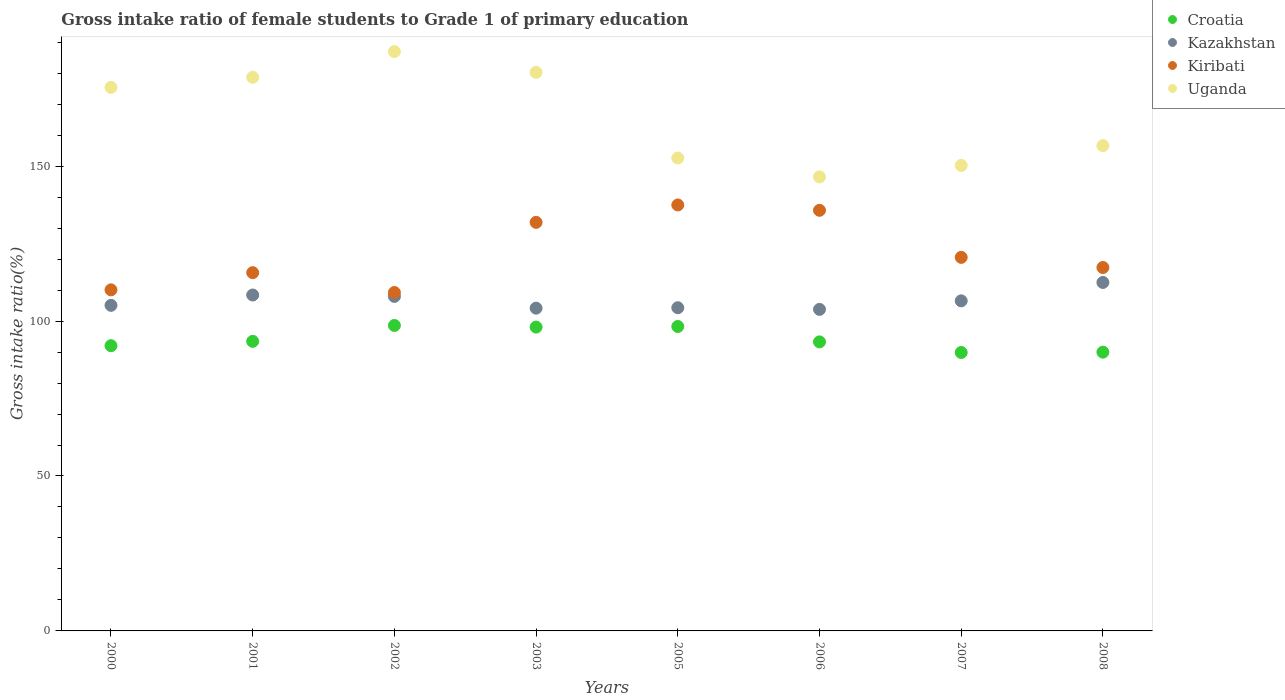Is the number of dotlines equal to the number of legend labels?
Make the answer very short. Yes. What is the gross intake ratio in Croatia in 2006?
Your answer should be compact. 93.28. Across all years, what is the maximum gross intake ratio in Croatia?
Offer a very short reply. 98.59. Across all years, what is the minimum gross intake ratio in Croatia?
Provide a succinct answer. 89.86. What is the total gross intake ratio in Kiribati in the graph?
Keep it short and to the point. 977.87. What is the difference between the gross intake ratio in Kiribati in 2001 and that in 2006?
Offer a very short reply. -20.13. What is the difference between the gross intake ratio in Croatia in 2003 and the gross intake ratio in Kazakhstan in 2007?
Give a very brief answer. -8.47. What is the average gross intake ratio in Kiribati per year?
Give a very brief answer. 122.23. In the year 2005, what is the difference between the gross intake ratio in Kiribati and gross intake ratio in Croatia?
Your answer should be very brief. 39.23. What is the ratio of the gross intake ratio in Uganda in 2002 to that in 2007?
Provide a succinct answer. 1.24. Is the gross intake ratio in Uganda in 2000 less than that in 2006?
Provide a short and direct response. No. Is the difference between the gross intake ratio in Kiribati in 2000 and 2007 greater than the difference between the gross intake ratio in Croatia in 2000 and 2007?
Provide a succinct answer. No. What is the difference between the highest and the second highest gross intake ratio in Croatia?
Provide a succinct answer. 0.33. What is the difference between the highest and the lowest gross intake ratio in Uganda?
Keep it short and to the point. 40.43. In how many years, is the gross intake ratio in Uganda greater than the average gross intake ratio in Uganda taken over all years?
Make the answer very short. 4. Does the gross intake ratio in Uganda monotonically increase over the years?
Your answer should be compact. No. Is the gross intake ratio in Kiribati strictly greater than the gross intake ratio in Uganda over the years?
Your answer should be very brief. No. How many dotlines are there?
Your answer should be very brief. 4. How many years are there in the graph?
Make the answer very short. 8. Are the values on the major ticks of Y-axis written in scientific E-notation?
Make the answer very short. No. How are the legend labels stacked?
Your response must be concise. Vertical. What is the title of the graph?
Give a very brief answer. Gross intake ratio of female students to Grade 1 of primary education. Does "Arab World" appear as one of the legend labels in the graph?
Provide a short and direct response. No. What is the label or title of the X-axis?
Keep it short and to the point. Years. What is the label or title of the Y-axis?
Ensure brevity in your answer.  Gross intake ratio(%). What is the Gross intake ratio(%) of Croatia in 2000?
Keep it short and to the point. 92.06. What is the Gross intake ratio(%) of Kazakhstan in 2000?
Offer a terse response. 105.08. What is the Gross intake ratio(%) in Kiribati in 2000?
Your answer should be compact. 110.08. What is the Gross intake ratio(%) of Uganda in 2000?
Your response must be concise. 175.42. What is the Gross intake ratio(%) in Croatia in 2001?
Keep it short and to the point. 93.46. What is the Gross intake ratio(%) in Kazakhstan in 2001?
Provide a succinct answer. 108.41. What is the Gross intake ratio(%) of Kiribati in 2001?
Give a very brief answer. 115.62. What is the Gross intake ratio(%) in Uganda in 2001?
Make the answer very short. 178.67. What is the Gross intake ratio(%) in Croatia in 2002?
Offer a terse response. 98.59. What is the Gross intake ratio(%) of Kazakhstan in 2002?
Offer a very short reply. 107.96. What is the Gross intake ratio(%) of Kiribati in 2002?
Ensure brevity in your answer.  109.23. What is the Gross intake ratio(%) in Uganda in 2002?
Your answer should be very brief. 186.96. What is the Gross intake ratio(%) of Croatia in 2003?
Offer a terse response. 98.06. What is the Gross intake ratio(%) in Kazakhstan in 2003?
Your response must be concise. 104.16. What is the Gross intake ratio(%) of Kiribati in 2003?
Make the answer very short. 131.86. What is the Gross intake ratio(%) in Uganda in 2003?
Your response must be concise. 180.28. What is the Gross intake ratio(%) of Croatia in 2005?
Your answer should be very brief. 98.25. What is the Gross intake ratio(%) of Kazakhstan in 2005?
Keep it short and to the point. 104.31. What is the Gross intake ratio(%) of Kiribati in 2005?
Offer a very short reply. 137.48. What is the Gross intake ratio(%) in Uganda in 2005?
Your answer should be very brief. 152.63. What is the Gross intake ratio(%) of Croatia in 2006?
Give a very brief answer. 93.28. What is the Gross intake ratio(%) in Kazakhstan in 2006?
Provide a succinct answer. 103.77. What is the Gross intake ratio(%) of Kiribati in 2006?
Provide a short and direct response. 135.75. What is the Gross intake ratio(%) in Uganda in 2006?
Your response must be concise. 146.53. What is the Gross intake ratio(%) of Croatia in 2007?
Make the answer very short. 89.86. What is the Gross intake ratio(%) in Kazakhstan in 2007?
Keep it short and to the point. 106.53. What is the Gross intake ratio(%) of Kiribati in 2007?
Offer a terse response. 120.56. What is the Gross intake ratio(%) of Uganda in 2007?
Ensure brevity in your answer.  150.23. What is the Gross intake ratio(%) in Croatia in 2008?
Make the answer very short. 89.97. What is the Gross intake ratio(%) of Kazakhstan in 2008?
Provide a succinct answer. 112.46. What is the Gross intake ratio(%) of Kiribati in 2008?
Make the answer very short. 117.29. What is the Gross intake ratio(%) of Uganda in 2008?
Your answer should be compact. 156.63. Across all years, what is the maximum Gross intake ratio(%) of Croatia?
Offer a very short reply. 98.59. Across all years, what is the maximum Gross intake ratio(%) in Kazakhstan?
Make the answer very short. 112.46. Across all years, what is the maximum Gross intake ratio(%) of Kiribati?
Your answer should be very brief. 137.48. Across all years, what is the maximum Gross intake ratio(%) of Uganda?
Your response must be concise. 186.96. Across all years, what is the minimum Gross intake ratio(%) of Croatia?
Provide a short and direct response. 89.86. Across all years, what is the minimum Gross intake ratio(%) of Kazakhstan?
Provide a short and direct response. 103.77. Across all years, what is the minimum Gross intake ratio(%) in Kiribati?
Your answer should be very brief. 109.23. Across all years, what is the minimum Gross intake ratio(%) of Uganda?
Your response must be concise. 146.53. What is the total Gross intake ratio(%) of Croatia in the graph?
Provide a short and direct response. 753.53. What is the total Gross intake ratio(%) in Kazakhstan in the graph?
Keep it short and to the point. 852.69. What is the total Gross intake ratio(%) of Kiribati in the graph?
Keep it short and to the point. 977.87. What is the total Gross intake ratio(%) of Uganda in the graph?
Offer a terse response. 1327.37. What is the difference between the Gross intake ratio(%) of Croatia in 2000 and that in 2001?
Keep it short and to the point. -1.4. What is the difference between the Gross intake ratio(%) in Kazakhstan in 2000 and that in 2001?
Make the answer very short. -3.33. What is the difference between the Gross intake ratio(%) in Kiribati in 2000 and that in 2001?
Provide a short and direct response. -5.54. What is the difference between the Gross intake ratio(%) of Uganda in 2000 and that in 2001?
Give a very brief answer. -3.25. What is the difference between the Gross intake ratio(%) of Croatia in 2000 and that in 2002?
Ensure brevity in your answer.  -6.53. What is the difference between the Gross intake ratio(%) in Kazakhstan in 2000 and that in 2002?
Your answer should be very brief. -2.88. What is the difference between the Gross intake ratio(%) in Kiribati in 2000 and that in 2002?
Keep it short and to the point. 0.85. What is the difference between the Gross intake ratio(%) in Uganda in 2000 and that in 2002?
Your answer should be very brief. -11.54. What is the difference between the Gross intake ratio(%) of Croatia in 2000 and that in 2003?
Offer a very short reply. -6. What is the difference between the Gross intake ratio(%) of Kazakhstan in 2000 and that in 2003?
Your answer should be very brief. 0.92. What is the difference between the Gross intake ratio(%) in Kiribati in 2000 and that in 2003?
Make the answer very short. -21.78. What is the difference between the Gross intake ratio(%) in Uganda in 2000 and that in 2003?
Ensure brevity in your answer.  -4.86. What is the difference between the Gross intake ratio(%) in Croatia in 2000 and that in 2005?
Your response must be concise. -6.2. What is the difference between the Gross intake ratio(%) in Kazakhstan in 2000 and that in 2005?
Make the answer very short. 0.77. What is the difference between the Gross intake ratio(%) in Kiribati in 2000 and that in 2005?
Keep it short and to the point. -27.4. What is the difference between the Gross intake ratio(%) of Uganda in 2000 and that in 2005?
Offer a terse response. 22.8. What is the difference between the Gross intake ratio(%) of Croatia in 2000 and that in 2006?
Provide a short and direct response. -1.23. What is the difference between the Gross intake ratio(%) of Kazakhstan in 2000 and that in 2006?
Your response must be concise. 1.31. What is the difference between the Gross intake ratio(%) in Kiribati in 2000 and that in 2006?
Offer a terse response. -25.67. What is the difference between the Gross intake ratio(%) in Uganda in 2000 and that in 2006?
Give a very brief answer. 28.89. What is the difference between the Gross intake ratio(%) in Croatia in 2000 and that in 2007?
Offer a very short reply. 2.2. What is the difference between the Gross intake ratio(%) of Kazakhstan in 2000 and that in 2007?
Your response must be concise. -1.45. What is the difference between the Gross intake ratio(%) of Kiribati in 2000 and that in 2007?
Your answer should be very brief. -10.48. What is the difference between the Gross intake ratio(%) of Uganda in 2000 and that in 2007?
Make the answer very short. 25.2. What is the difference between the Gross intake ratio(%) of Croatia in 2000 and that in 2008?
Your response must be concise. 2.09. What is the difference between the Gross intake ratio(%) of Kazakhstan in 2000 and that in 2008?
Your answer should be compact. -7.38. What is the difference between the Gross intake ratio(%) in Kiribati in 2000 and that in 2008?
Keep it short and to the point. -7.21. What is the difference between the Gross intake ratio(%) of Uganda in 2000 and that in 2008?
Your response must be concise. 18.79. What is the difference between the Gross intake ratio(%) of Croatia in 2001 and that in 2002?
Ensure brevity in your answer.  -5.13. What is the difference between the Gross intake ratio(%) of Kazakhstan in 2001 and that in 2002?
Provide a succinct answer. 0.45. What is the difference between the Gross intake ratio(%) of Kiribati in 2001 and that in 2002?
Your answer should be very brief. 6.4. What is the difference between the Gross intake ratio(%) in Uganda in 2001 and that in 2002?
Keep it short and to the point. -8.29. What is the difference between the Gross intake ratio(%) in Croatia in 2001 and that in 2003?
Your response must be concise. -4.6. What is the difference between the Gross intake ratio(%) of Kazakhstan in 2001 and that in 2003?
Keep it short and to the point. 4.25. What is the difference between the Gross intake ratio(%) in Kiribati in 2001 and that in 2003?
Offer a very short reply. -16.23. What is the difference between the Gross intake ratio(%) in Uganda in 2001 and that in 2003?
Provide a short and direct response. -1.61. What is the difference between the Gross intake ratio(%) in Croatia in 2001 and that in 2005?
Your response must be concise. -4.79. What is the difference between the Gross intake ratio(%) of Kazakhstan in 2001 and that in 2005?
Offer a very short reply. 4.1. What is the difference between the Gross intake ratio(%) of Kiribati in 2001 and that in 2005?
Give a very brief answer. -21.85. What is the difference between the Gross intake ratio(%) of Uganda in 2001 and that in 2005?
Ensure brevity in your answer.  26.05. What is the difference between the Gross intake ratio(%) of Croatia in 2001 and that in 2006?
Give a very brief answer. 0.18. What is the difference between the Gross intake ratio(%) of Kazakhstan in 2001 and that in 2006?
Give a very brief answer. 4.64. What is the difference between the Gross intake ratio(%) of Kiribati in 2001 and that in 2006?
Give a very brief answer. -20.13. What is the difference between the Gross intake ratio(%) of Uganda in 2001 and that in 2006?
Provide a succinct answer. 32.14. What is the difference between the Gross intake ratio(%) of Croatia in 2001 and that in 2007?
Your response must be concise. 3.6. What is the difference between the Gross intake ratio(%) of Kazakhstan in 2001 and that in 2007?
Your answer should be very brief. 1.88. What is the difference between the Gross intake ratio(%) in Kiribati in 2001 and that in 2007?
Give a very brief answer. -4.94. What is the difference between the Gross intake ratio(%) of Uganda in 2001 and that in 2007?
Your answer should be compact. 28.45. What is the difference between the Gross intake ratio(%) of Croatia in 2001 and that in 2008?
Provide a short and direct response. 3.49. What is the difference between the Gross intake ratio(%) in Kazakhstan in 2001 and that in 2008?
Ensure brevity in your answer.  -4.05. What is the difference between the Gross intake ratio(%) in Kiribati in 2001 and that in 2008?
Provide a short and direct response. -1.66. What is the difference between the Gross intake ratio(%) of Uganda in 2001 and that in 2008?
Make the answer very short. 22.04. What is the difference between the Gross intake ratio(%) of Croatia in 2002 and that in 2003?
Ensure brevity in your answer.  0.53. What is the difference between the Gross intake ratio(%) of Kazakhstan in 2002 and that in 2003?
Offer a very short reply. 3.8. What is the difference between the Gross intake ratio(%) of Kiribati in 2002 and that in 2003?
Ensure brevity in your answer.  -22.63. What is the difference between the Gross intake ratio(%) in Uganda in 2002 and that in 2003?
Keep it short and to the point. 6.68. What is the difference between the Gross intake ratio(%) of Croatia in 2002 and that in 2005?
Provide a short and direct response. 0.33. What is the difference between the Gross intake ratio(%) of Kazakhstan in 2002 and that in 2005?
Offer a very short reply. 3.65. What is the difference between the Gross intake ratio(%) of Kiribati in 2002 and that in 2005?
Provide a succinct answer. -28.25. What is the difference between the Gross intake ratio(%) of Uganda in 2002 and that in 2005?
Your answer should be very brief. 34.33. What is the difference between the Gross intake ratio(%) in Croatia in 2002 and that in 2006?
Keep it short and to the point. 5.3. What is the difference between the Gross intake ratio(%) in Kazakhstan in 2002 and that in 2006?
Your answer should be compact. 4.19. What is the difference between the Gross intake ratio(%) in Kiribati in 2002 and that in 2006?
Ensure brevity in your answer.  -26.52. What is the difference between the Gross intake ratio(%) of Uganda in 2002 and that in 2006?
Offer a very short reply. 40.43. What is the difference between the Gross intake ratio(%) of Croatia in 2002 and that in 2007?
Keep it short and to the point. 8.73. What is the difference between the Gross intake ratio(%) of Kazakhstan in 2002 and that in 2007?
Keep it short and to the point. 1.43. What is the difference between the Gross intake ratio(%) in Kiribati in 2002 and that in 2007?
Keep it short and to the point. -11.34. What is the difference between the Gross intake ratio(%) of Uganda in 2002 and that in 2007?
Provide a short and direct response. 36.73. What is the difference between the Gross intake ratio(%) of Croatia in 2002 and that in 2008?
Provide a succinct answer. 8.62. What is the difference between the Gross intake ratio(%) in Kazakhstan in 2002 and that in 2008?
Provide a succinct answer. -4.5. What is the difference between the Gross intake ratio(%) of Kiribati in 2002 and that in 2008?
Offer a very short reply. -8.06. What is the difference between the Gross intake ratio(%) in Uganda in 2002 and that in 2008?
Your answer should be very brief. 30.33. What is the difference between the Gross intake ratio(%) in Croatia in 2003 and that in 2005?
Keep it short and to the point. -0.19. What is the difference between the Gross intake ratio(%) in Kazakhstan in 2003 and that in 2005?
Keep it short and to the point. -0.14. What is the difference between the Gross intake ratio(%) in Kiribati in 2003 and that in 2005?
Offer a terse response. -5.62. What is the difference between the Gross intake ratio(%) of Uganda in 2003 and that in 2005?
Offer a very short reply. 27.65. What is the difference between the Gross intake ratio(%) in Croatia in 2003 and that in 2006?
Keep it short and to the point. 4.78. What is the difference between the Gross intake ratio(%) of Kazakhstan in 2003 and that in 2006?
Keep it short and to the point. 0.39. What is the difference between the Gross intake ratio(%) of Kiribati in 2003 and that in 2006?
Offer a terse response. -3.89. What is the difference between the Gross intake ratio(%) of Uganda in 2003 and that in 2006?
Make the answer very short. 33.75. What is the difference between the Gross intake ratio(%) of Croatia in 2003 and that in 2007?
Give a very brief answer. 8.2. What is the difference between the Gross intake ratio(%) of Kazakhstan in 2003 and that in 2007?
Provide a short and direct response. -2.36. What is the difference between the Gross intake ratio(%) in Kiribati in 2003 and that in 2007?
Offer a very short reply. 11.29. What is the difference between the Gross intake ratio(%) of Uganda in 2003 and that in 2007?
Ensure brevity in your answer.  30.05. What is the difference between the Gross intake ratio(%) of Croatia in 2003 and that in 2008?
Ensure brevity in your answer.  8.09. What is the difference between the Gross intake ratio(%) in Kazakhstan in 2003 and that in 2008?
Keep it short and to the point. -8.3. What is the difference between the Gross intake ratio(%) of Kiribati in 2003 and that in 2008?
Keep it short and to the point. 14.57. What is the difference between the Gross intake ratio(%) in Uganda in 2003 and that in 2008?
Your response must be concise. 23.65. What is the difference between the Gross intake ratio(%) of Croatia in 2005 and that in 2006?
Make the answer very short. 4.97. What is the difference between the Gross intake ratio(%) in Kazakhstan in 2005 and that in 2006?
Offer a terse response. 0.53. What is the difference between the Gross intake ratio(%) in Kiribati in 2005 and that in 2006?
Provide a succinct answer. 1.73. What is the difference between the Gross intake ratio(%) in Uganda in 2005 and that in 2006?
Provide a short and direct response. 6.09. What is the difference between the Gross intake ratio(%) in Croatia in 2005 and that in 2007?
Keep it short and to the point. 8.39. What is the difference between the Gross intake ratio(%) of Kazakhstan in 2005 and that in 2007?
Ensure brevity in your answer.  -2.22. What is the difference between the Gross intake ratio(%) of Kiribati in 2005 and that in 2007?
Keep it short and to the point. 16.91. What is the difference between the Gross intake ratio(%) in Uganda in 2005 and that in 2007?
Ensure brevity in your answer.  2.4. What is the difference between the Gross intake ratio(%) of Croatia in 2005 and that in 2008?
Give a very brief answer. 8.29. What is the difference between the Gross intake ratio(%) in Kazakhstan in 2005 and that in 2008?
Your answer should be very brief. -8.16. What is the difference between the Gross intake ratio(%) of Kiribati in 2005 and that in 2008?
Provide a succinct answer. 20.19. What is the difference between the Gross intake ratio(%) in Uganda in 2005 and that in 2008?
Provide a short and direct response. -4. What is the difference between the Gross intake ratio(%) in Croatia in 2006 and that in 2007?
Your response must be concise. 3.43. What is the difference between the Gross intake ratio(%) in Kazakhstan in 2006 and that in 2007?
Offer a terse response. -2.76. What is the difference between the Gross intake ratio(%) in Kiribati in 2006 and that in 2007?
Your answer should be very brief. 15.19. What is the difference between the Gross intake ratio(%) of Uganda in 2006 and that in 2007?
Your response must be concise. -3.69. What is the difference between the Gross intake ratio(%) in Croatia in 2006 and that in 2008?
Keep it short and to the point. 3.32. What is the difference between the Gross intake ratio(%) in Kazakhstan in 2006 and that in 2008?
Keep it short and to the point. -8.69. What is the difference between the Gross intake ratio(%) of Kiribati in 2006 and that in 2008?
Your response must be concise. 18.47. What is the difference between the Gross intake ratio(%) in Uganda in 2006 and that in 2008?
Your answer should be very brief. -10.1. What is the difference between the Gross intake ratio(%) of Croatia in 2007 and that in 2008?
Ensure brevity in your answer.  -0.11. What is the difference between the Gross intake ratio(%) in Kazakhstan in 2007 and that in 2008?
Keep it short and to the point. -5.93. What is the difference between the Gross intake ratio(%) in Kiribati in 2007 and that in 2008?
Offer a very short reply. 3.28. What is the difference between the Gross intake ratio(%) in Uganda in 2007 and that in 2008?
Your answer should be very brief. -6.4. What is the difference between the Gross intake ratio(%) of Croatia in 2000 and the Gross intake ratio(%) of Kazakhstan in 2001?
Make the answer very short. -16.35. What is the difference between the Gross intake ratio(%) of Croatia in 2000 and the Gross intake ratio(%) of Kiribati in 2001?
Give a very brief answer. -23.57. What is the difference between the Gross intake ratio(%) in Croatia in 2000 and the Gross intake ratio(%) in Uganda in 2001?
Offer a terse response. -86.62. What is the difference between the Gross intake ratio(%) in Kazakhstan in 2000 and the Gross intake ratio(%) in Kiribati in 2001?
Your answer should be very brief. -10.54. What is the difference between the Gross intake ratio(%) of Kazakhstan in 2000 and the Gross intake ratio(%) of Uganda in 2001?
Offer a very short reply. -73.59. What is the difference between the Gross intake ratio(%) of Kiribati in 2000 and the Gross intake ratio(%) of Uganda in 2001?
Provide a short and direct response. -68.59. What is the difference between the Gross intake ratio(%) of Croatia in 2000 and the Gross intake ratio(%) of Kazakhstan in 2002?
Provide a succinct answer. -15.9. What is the difference between the Gross intake ratio(%) of Croatia in 2000 and the Gross intake ratio(%) of Kiribati in 2002?
Offer a terse response. -17.17. What is the difference between the Gross intake ratio(%) in Croatia in 2000 and the Gross intake ratio(%) in Uganda in 2002?
Your answer should be very brief. -94.91. What is the difference between the Gross intake ratio(%) of Kazakhstan in 2000 and the Gross intake ratio(%) of Kiribati in 2002?
Ensure brevity in your answer.  -4.15. What is the difference between the Gross intake ratio(%) in Kazakhstan in 2000 and the Gross intake ratio(%) in Uganda in 2002?
Give a very brief answer. -81.88. What is the difference between the Gross intake ratio(%) in Kiribati in 2000 and the Gross intake ratio(%) in Uganda in 2002?
Give a very brief answer. -76.88. What is the difference between the Gross intake ratio(%) of Croatia in 2000 and the Gross intake ratio(%) of Kazakhstan in 2003?
Ensure brevity in your answer.  -12.11. What is the difference between the Gross intake ratio(%) in Croatia in 2000 and the Gross intake ratio(%) in Kiribati in 2003?
Give a very brief answer. -39.8. What is the difference between the Gross intake ratio(%) of Croatia in 2000 and the Gross intake ratio(%) of Uganda in 2003?
Give a very brief answer. -88.22. What is the difference between the Gross intake ratio(%) of Kazakhstan in 2000 and the Gross intake ratio(%) of Kiribati in 2003?
Keep it short and to the point. -26.78. What is the difference between the Gross intake ratio(%) in Kazakhstan in 2000 and the Gross intake ratio(%) in Uganda in 2003?
Keep it short and to the point. -75.2. What is the difference between the Gross intake ratio(%) in Kiribati in 2000 and the Gross intake ratio(%) in Uganda in 2003?
Ensure brevity in your answer.  -70.2. What is the difference between the Gross intake ratio(%) in Croatia in 2000 and the Gross intake ratio(%) in Kazakhstan in 2005?
Make the answer very short. -12.25. What is the difference between the Gross intake ratio(%) of Croatia in 2000 and the Gross intake ratio(%) of Kiribati in 2005?
Offer a terse response. -45.42. What is the difference between the Gross intake ratio(%) of Croatia in 2000 and the Gross intake ratio(%) of Uganda in 2005?
Offer a terse response. -60.57. What is the difference between the Gross intake ratio(%) in Kazakhstan in 2000 and the Gross intake ratio(%) in Kiribati in 2005?
Give a very brief answer. -32.4. What is the difference between the Gross intake ratio(%) in Kazakhstan in 2000 and the Gross intake ratio(%) in Uganda in 2005?
Keep it short and to the point. -47.55. What is the difference between the Gross intake ratio(%) in Kiribati in 2000 and the Gross intake ratio(%) in Uganda in 2005?
Provide a succinct answer. -42.55. What is the difference between the Gross intake ratio(%) of Croatia in 2000 and the Gross intake ratio(%) of Kazakhstan in 2006?
Ensure brevity in your answer.  -11.72. What is the difference between the Gross intake ratio(%) in Croatia in 2000 and the Gross intake ratio(%) in Kiribati in 2006?
Give a very brief answer. -43.7. What is the difference between the Gross intake ratio(%) of Croatia in 2000 and the Gross intake ratio(%) of Uganda in 2006?
Give a very brief answer. -54.48. What is the difference between the Gross intake ratio(%) in Kazakhstan in 2000 and the Gross intake ratio(%) in Kiribati in 2006?
Your answer should be very brief. -30.67. What is the difference between the Gross intake ratio(%) of Kazakhstan in 2000 and the Gross intake ratio(%) of Uganda in 2006?
Offer a terse response. -41.45. What is the difference between the Gross intake ratio(%) in Kiribati in 2000 and the Gross intake ratio(%) in Uganda in 2006?
Provide a succinct answer. -36.45. What is the difference between the Gross intake ratio(%) in Croatia in 2000 and the Gross intake ratio(%) in Kazakhstan in 2007?
Your answer should be compact. -14.47. What is the difference between the Gross intake ratio(%) in Croatia in 2000 and the Gross intake ratio(%) in Kiribati in 2007?
Your answer should be compact. -28.51. What is the difference between the Gross intake ratio(%) in Croatia in 2000 and the Gross intake ratio(%) in Uganda in 2007?
Make the answer very short. -58.17. What is the difference between the Gross intake ratio(%) in Kazakhstan in 2000 and the Gross intake ratio(%) in Kiribati in 2007?
Offer a terse response. -15.48. What is the difference between the Gross intake ratio(%) of Kazakhstan in 2000 and the Gross intake ratio(%) of Uganda in 2007?
Your answer should be compact. -45.15. What is the difference between the Gross intake ratio(%) in Kiribati in 2000 and the Gross intake ratio(%) in Uganda in 2007?
Your answer should be compact. -40.15. What is the difference between the Gross intake ratio(%) in Croatia in 2000 and the Gross intake ratio(%) in Kazakhstan in 2008?
Offer a terse response. -20.41. What is the difference between the Gross intake ratio(%) in Croatia in 2000 and the Gross intake ratio(%) in Kiribati in 2008?
Provide a succinct answer. -25.23. What is the difference between the Gross intake ratio(%) of Croatia in 2000 and the Gross intake ratio(%) of Uganda in 2008?
Make the answer very short. -64.58. What is the difference between the Gross intake ratio(%) of Kazakhstan in 2000 and the Gross intake ratio(%) of Kiribati in 2008?
Provide a succinct answer. -12.21. What is the difference between the Gross intake ratio(%) in Kazakhstan in 2000 and the Gross intake ratio(%) in Uganda in 2008?
Offer a very short reply. -51.55. What is the difference between the Gross intake ratio(%) in Kiribati in 2000 and the Gross intake ratio(%) in Uganda in 2008?
Your answer should be compact. -46.55. What is the difference between the Gross intake ratio(%) in Croatia in 2001 and the Gross intake ratio(%) in Kazakhstan in 2002?
Ensure brevity in your answer.  -14.5. What is the difference between the Gross intake ratio(%) of Croatia in 2001 and the Gross intake ratio(%) of Kiribati in 2002?
Your answer should be very brief. -15.77. What is the difference between the Gross intake ratio(%) of Croatia in 2001 and the Gross intake ratio(%) of Uganda in 2002?
Your response must be concise. -93.5. What is the difference between the Gross intake ratio(%) in Kazakhstan in 2001 and the Gross intake ratio(%) in Kiribati in 2002?
Your answer should be very brief. -0.82. What is the difference between the Gross intake ratio(%) in Kazakhstan in 2001 and the Gross intake ratio(%) in Uganda in 2002?
Provide a short and direct response. -78.55. What is the difference between the Gross intake ratio(%) in Kiribati in 2001 and the Gross intake ratio(%) in Uganda in 2002?
Make the answer very short. -71.34. What is the difference between the Gross intake ratio(%) in Croatia in 2001 and the Gross intake ratio(%) in Kazakhstan in 2003?
Your answer should be very brief. -10.7. What is the difference between the Gross intake ratio(%) of Croatia in 2001 and the Gross intake ratio(%) of Kiribati in 2003?
Ensure brevity in your answer.  -38.4. What is the difference between the Gross intake ratio(%) in Croatia in 2001 and the Gross intake ratio(%) in Uganda in 2003?
Offer a terse response. -86.82. What is the difference between the Gross intake ratio(%) of Kazakhstan in 2001 and the Gross intake ratio(%) of Kiribati in 2003?
Your answer should be very brief. -23.45. What is the difference between the Gross intake ratio(%) of Kazakhstan in 2001 and the Gross intake ratio(%) of Uganda in 2003?
Your answer should be very brief. -71.87. What is the difference between the Gross intake ratio(%) in Kiribati in 2001 and the Gross intake ratio(%) in Uganda in 2003?
Your answer should be very brief. -64.66. What is the difference between the Gross intake ratio(%) in Croatia in 2001 and the Gross intake ratio(%) in Kazakhstan in 2005?
Your answer should be compact. -10.85. What is the difference between the Gross intake ratio(%) in Croatia in 2001 and the Gross intake ratio(%) in Kiribati in 2005?
Give a very brief answer. -44.02. What is the difference between the Gross intake ratio(%) in Croatia in 2001 and the Gross intake ratio(%) in Uganda in 2005?
Make the answer very short. -59.17. What is the difference between the Gross intake ratio(%) in Kazakhstan in 2001 and the Gross intake ratio(%) in Kiribati in 2005?
Your answer should be compact. -29.07. What is the difference between the Gross intake ratio(%) of Kazakhstan in 2001 and the Gross intake ratio(%) of Uganda in 2005?
Give a very brief answer. -44.22. What is the difference between the Gross intake ratio(%) in Kiribati in 2001 and the Gross intake ratio(%) in Uganda in 2005?
Your response must be concise. -37. What is the difference between the Gross intake ratio(%) of Croatia in 2001 and the Gross intake ratio(%) of Kazakhstan in 2006?
Offer a terse response. -10.31. What is the difference between the Gross intake ratio(%) of Croatia in 2001 and the Gross intake ratio(%) of Kiribati in 2006?
Keep it short and to the point. -42.29. What is the difference between the Gross intake ratio(%) of Croatia in 2001 and the Gross intake ratio(%) of Uganda in 2006?
Provide a succinct answer. -53.07. What is the difference between the Gross intake ratio(%) in Kazakhstan in 2001 and the Gross intake ratio(%) in Kiribati in 2006?
Provide a succinct answer. -27.34. What is the difference between the Gross intake ratio(%) of Kazakhstan in 2001 and the Gross intake ratio(%) of Uganda in 2006?
Your answer should be very brief. -38.12. What is the difference between the Gross intake ratio(%) of Kiribati in 2001 and the Gross intake ratio(%) of Uganda in 2006?
Make the answer very short. -30.91. What is the difference between the Gross intake ratio(%) of Croatia in 2001 and the Gross intake ratio(%) of Kazakhstan in 2007?
Provide a short and direct response. -13.07. What is the difference between the Gross intake ratio(%) in Croatia in 2001 and the Gross intake ratio(%) in Kiribati in 2007?
Give a very brief answer. -27.1. What is the difference between the Gross intake ratio(%) of Croatia in 2001 and the Gross intake ratio(%) of Uganda in 2007?
Offer a terse response. -56.77. What is the difference between the Gross intake ratio(%) of Kazakhstan in 2001 and the Gross intake ratio(%) of Kiribati in 2007?
Offer a terse response. -12.15. What is the difference between the Gross intake ratio(%) of Kazakhstan in 2001 and the Gross intake ratio(%) of Uganda in 2007?
Your answer should be compact. -41.82. What is the difference between the Gross intake ratio(%) of Kiribati in 2001 and the Gross intake ratio(%) of Uganda in 2007?
Offer a terse response. -34.6. What is the difference between the Gross intake ratio(%) of Croatia in 2001 and the Gross intake ratio(%) of Kazakhstan in 2008?
Ensure brevity in your answer.  -19. What is the difference between the Gross intake ratio(%) in Croatia in 2001 and the Gross intake ratio(%) in Kiribati in 2008?
Your response must be concise. -23.83. What is the difference between the Gross intake ratio(%) in Croatia in 2001 and the Gross intake ratio(%) in Uganda in 2008?
Give a very brief answer. -63.17. What is the difference between the Gross intake ratio(%) in Kazakhstan in 2001 and the Gross intake ratio(%) in Kiribati in 2008?
Your response must be concise. -8.88. What is the difference between the Gross intake ratio(%) of Kazakhstan in 2001 and the Gross intake ratio(%) of Uganda in 2008?
Your answer should be compact. -48.22. What is the difference between the Gross intake ratio(%) of Kiribati in 2001 and the Gross intake ratio(%) of Uganda in 2008?
Provide a succinct answer. -41.01. What is the difference between the Gross intake ratio(%) in Croatia in 2002 and the Gross intake ratio(%) in Kazakhstan in 2003?
Offer a very short reply. -5.58. What is the difference between the Gross intake ratio(%) of Croatia in 2002 and the Gross intake ratio(%) of Kiribati in 2003?
Your response must be concise. -33.27. What is the difference between the Gross intake ratio(%) of Croatia in 2002 and the Gross intake ratio(%) of Uganda in 2003?
Your answer should be compact. -81.69. What is the difference between the Gross intake ratio(%) in Kazakhstan in 2002 and the Gross intake ratio(%) in Kiribati in 2003?
Offer a terse response. -23.9. What is the difference between the Gross intake ratio(%) in Kazakhstan in 2002 and the Gross intake ratio(%) in Uganda in 2003?
Provide a short and direct response. -72.32. What is the difference between the Gross intake ratio(%) of Kiribati in 2002 and the Gross intake ratio(%) of Uganda in 2003?
Give a very brief answer. -71.05. What is the difference between the Gross intake ratio(%) of Croatia in 2002 and the Gross intake ratio(%) of Kazakhstan in 2005?
Provide a succinct answer. -5.72. What is the difference between the Gross intake ratio(%) in Croatia in 2002 and the Gross intake ratio(%) in Kiribati in 2005?
Provide a short and direct response. -38.89. What is the difference between the Gross intake ratio(%) in Croatia in 2002 and the Gross intake ratio(%) in Uganda in 2005?
Keep it short and to the point. -54.04. What is the difference between the Gross intake ratio(%) in Kazakhstan in 2002 and the Gross intake ratio(%) in Kiribati in 2005?
Give a very brief answer. -29.52. What is the difference between the Gross intake ratio(%) in Kazakhstan in 2002 and the Gross intake ratio(%) in Uganda in 2005?
Offer a very short reply. -44.67. What is the difference between the Gross intake ratio(%) in Kiribati in 2002 and the Gross intake ratio(%) in Uganda in 2005?
Provide a succinct answer. -43.4. What is the difference between the Gross intake ratio(%) of Croatia in 2002 and the Gross intake ratio(%) of Kazakhstan in 2006?
Your answer should be compact. -5.19. What is the difference between the Gross intake ratio(%) in Croatia in 2002 and the Gross intake ratio(%) in Kiribati in 2006?
Offer a very short reply. -37.17. What is the difference between the Gross intake ratio(%) of Croatia in 2002 and the Gross intake ratio(%) of Uganda in 2006?
Make the answer very short. -47.95. What is the difference between the Gross intake ratio(%) of Kazakhstan in 2002 and the Gross intake ratio(%) of Kiribati in 2006?
Provide a succinct answer. -27.79. What is the difference between the Gross intake ratio(%) in Kazakhstan in 2002 and the Gross intake ratio(%) in Uganda in 2006?
Offer a very short reply. -38.57. What is the difference between the Gross intake ratio(%) of Kiribati in 2002 and the Gross intake ratio(%) of Uganda in 2006?
Provide a succinct answer. -37.31. What is the difference between the Gross intake ratio(%) in Croatia in 2002 and the Gross intake ratio(%) in Kazakhstan in 2007?
Give a very brief answer. -7.94. What is the difference between the Gross intake ratio(%) of Croatia in 2002 and the Gross intake ratio(%) of Kiribati in 2007?
Provide a short and direct response. -21.98. What is the difference between the Gross intake ratio(%) in Croatia in 2002 and the Gross intake ratio(%) in Uganda in 2007?
Your answer should be compact. -51.64. What is the difference between the Gross intake ratio(%) in Kazakhstan in 2002 and the Gross intake ratio(%) in Kiribati in 2007?
Keep it short and to the point. -12.6. What is the difference between the Gross intake ratio(%) in Kazakhstan in 2002 and the Gross intake ratio(%) in Uganda in 2007?
Your response must be concise. -42.27. What is the difference between the Gross intake ratio(%) of Kiribati in 2002 and the Gross intake ratio(%) of Uganda in 2007?
Make the answer very short. -41. What is the difference between the Gross intake ratio(%) in Croatia in 2002 and the Gross intake ratio(%) in Kazakhstan in 2008?
Offer a very short reply. -13.88. What is the difference between the Gross intake ratio(%) in Croatia in 2002 and the Gross intake ratio(%) in Kiribati in 2008?
Give a very brief answer. -18.7. What is the difference between the Gross intake ratio(%) of Croatia in 2002 and the Gross intake ratio(%) of Uganda in 2008?
Your answer should be very brief. -58.05. What is the difference between the Gross intake ratio(%) in Kazakhstan in 2002 and the Gross intake ratio(%) in Kiribati in 2008?
Provide a short and direct response. -9.33. What is the difference between the Gross intake ratio(%) of Kazakhstan in 2002 and the Gross intake ratio(%) of Uganda in 2008?
Offer a terse response. -48.67. What is the difference between the Gross intake ratio(%) in Kiribati in 2002 and the Gross intake ratio(%) in Uganda in 2008?
Your answer should be very brief. -47.41. What is the difference between the Gross intake ratio(%) of Croatia in 2003 and the Gross intake ratio(%) of Kazakhstan in 2005?
Ensure brevity in your answer.  -6.25. What is the difference between the Gross intake ratio(%) of Croatia in 2003 and the Gross intake ratio(%) of Kiribati in 2005?
Provide a short and direct response. -39.42. What is the difference between the Gross intake ratio(%) of Croatia in 2003 and the Gross intake ratio(%) of Uganda in 2005?
Offer a very short reply. -54.57. What is the difference between the Gross intake ratio(%) in Kazakhstan in 2003 and the Gross intake ratio(%) in Kiribati in 2005?
Keep it short and to the point. -33.31. What is the difference between the Gross intake ratio(%) in Kazakhstan in 2003 and the Gross intake ratio(%) in Uganda in 2005?
Your response must be concise. -48.46. What is the difference between the Gross intake ratio(%) in Kiribati in 2003 and the Gross intake ratio(%) in Uganda in 2005?
Your response must be concise. -20.77. What is the difference between the Gross intake ratio(%) of Croatia in 2003 and the Gross intake ratio(%) of Kazakhstan in 2006?
Keep it short and to the point. -5.71. What is the difference between the Gross intake ratio(%) of Croatia in 2003 and the Gross intake ratio(%) of Kiribati in 2006?
Your answer should be compact. -37.69. What is the difference between the Gross intake ratio(%) of Croatia in 2003 and the Gross intake ratio(%) of Uganda in 2006?
Your answer should be compact. -48.47. What is the difference between the Gross intake ratio(%) of Kazakhstan in 2003 and the Gross intake ratio(%) of Kiribati in 2006?
Your response must be concise. -31.59. What is the difference between the Gross intake ratio(%) of Kazakhstan in 2003 and the Gross intake ratio(%) of Uganda in 2006?
Keep it short and to the point. -42.37. What is the difference between the Gross intake ratio(%) of Kiribati in 2003 and the Gross intake ratio(%) of Uganda in 2006?
Your response must be concise. -14.68. What is the difference between the Gross intake ratio(%) in Croatia in 2003 and the Gross intake ratio(%) in Kazakhstan in 2007?
Offer a very short reply. -8.47. What is the difference between the Gross intake ratio(%) in Croatia in 2003 and the Gross intake ratio(%) in Kiribati in 2007?
Ensure brevity in your answer.  -22.5. What is the difference between the Gross intake ratio(%) in Croatia in 2003 and the Gross intake ratio(%) in Uganda in 2007?
Make the answer very short. -52.17. What is the difference between the Gross intake ratio(%) of Kazakhstan in 2003 and the Gross intake ratio(%) of Kiribati in 2007?
Your response must be concise. -16.4. What is the difference between the Gross intake ratio(%) in Kazakhstan in 2003 and the Gross intake ratio(%) in Uganda in 2007?
Offer a very short reply. -46.06. What is the difference between the Gross intake ratio(%) of Kiribati in 2003 and the Gross intake ratio(%) of Uganda in 2007?
Make the answer very short. -18.37. What is the difference between the Gross intake ratio(%) of Croatia in 2003 and the Gross intake ratio(%) of Kazakhstan in 2008?
Provide a short and direct response. -14.4. What is the difference between the Gross intake ratio(%) in Croatia in 2003 and the Gross intake ratio(%) in Kiribati in 2008?
Provide a short and direct response. -19.23. What is the difference between the Gross intake ratio(%) in Croatia in 2003 and the Gross intake ratio(%) in Uganda in 2008?
Offer a terse response. -58.57. What is the difference between the Gross intake ratio(%) in Kazakhstan in 2003 and the Gross intake ratio(%) in Kiribati in 2008?
Provide a succinct answer. -13.12. What is the difference between the Gross intake ratio(%) of Kazakhstan in 2003 and the Gross intake ratio(%) of Uganda in 2008?
Give a very brief answer. -52.47. What is the difference between the Gross intake ratio(%) in Kiribati in 2003 and the Gross intake ratio(%) in Uganda in 2008?
Your answer should be very brief. -24.77. What is the difference between the Gross intake ratio(%) of Croatia in 2005 and the Gross intake ratio(%) of Kazakhstan in 2006?
Keep it short and to the point. -5.52. What is the difference between the Gross intake ratio(%) of Croatia in 2005 and the Gross intake ratio(%) of Kiribati in 2006?
Make the answer very short. -37.5. What is the difference between the Gross intake ratio(%) of Croatia in 2005 and the Gross intake ratio(%) of Uganda in 2006?
Offer a terse response. -48.28. What is the difference between the Gross intake ratio(%) in Kazakhstan in 2005 and the Gross intake ratio(%) in Kiribati in 2006?
Provide a succinct answer. -31.45. What is the difference between the Gross intake ratio(%) in Kazakhstan in 2005 and the Gross intake ratio(%) in Uganda in 2006?
Give a very brief answer. -42.23. What is the difference between the Gross intake ratio(%) in Kiribati in 2005 and the Gross intake ratio(%) in Uganda in 2006?
Provide a short and direct response. -9.06. What is the difference between the Gross intake ratio(%) of Croatia in 2005 and the Gross intake ratio(%) of Kazakhstan in 2007?
Provide a short and direct response. -8.28. What is the difference between the Gross intake ratio(%) in Croatia in 2005 and the Gross intake ratio(%) in Kiribati in 2007?
Your answer should be very brief. -22.31. What is the difference between the Gross intake ratio(%) of Croatia in 2005 and the Gross intake ratio(%) of Uganda in 2007?
Provide a short and direct response. -51.98. What is the difference between the Gross intake ratio(%) in Kazakhstan in 2005 and the Gross intake ratio(%) in Kiribati in 2007?
Your answer should be compact. -16.26. What is the difference between the Gross intake ratio(%) in Kazakhstan in 2005 and the Gross intake ratio(%) in Uganda in 2007?
Offer a terse response. -45.92. What is the difference between the Gross intake ratio(%) of Kiribati in 2005 and the Gross intake ratio(%) of Uganda in 2007?
Your answer should be compact. -12.75. What is the difference between the Gross intake ratio(%) in Croatia in 2005 and the Gross intake ratio(%) in Kazakhstan in 2008?
Offer a very short reply. -14.21. What is the difference between the Gross intake ratio(%) of Croatia in 2005 and the Gross intake ratio(%) of Kiribati in 2008?
Offer a terse response. -19.03. What is the difference between the Gross intake ratio(%) in Croatia in 2005 and the Gross intake ratio(%) in Uganda in 2008?
Offer a very short reply. -58.38. What is the difference between the Gross intake ratio(%) in Kazakhstan in 2005 and the Gross intake ratio(%) in Kiribati in 2008?
Provide a succinct answer. -12.98. What is the difference between the Gross intake ratio(%) in Kazakhstan in 2005 and the Gross intake ratio(%) in Uganda in 2008?
Your answer should be compact. -52.33. What is the difference between the Gross intake ratio(%) in Kiribati in 2005 and the Gross intake ratio(%) in Uganda in 2008?
Your answer should be compact. -19.16. What is the difference between the Gross intake ratio(%) in Croatia in 2006 and the Gross intake ratio(%) in Kazakhstan in 2007?
Your response must be concise. -13.24. What is the difference between the Gross intake ratio(%) of Croatia in 2006 and the Gross intake ratio(%) of Kiribati in 2007?
Offer a very short reply. -27.28. What is the difference between the Gross intake ratio(%) in Croatia in 2006 and the Gross intake ratio(%) in Uganda in 2007?
Provide a succinct answer. -56.94. What is the difference between the Gross intake ratio(%) of Kazakhstan in 2006 and the Gross intake ratio(%) of Kiribati in 2007?
Offer a terse response. -16.79. What is the difference between the Gross intake ratio(%) in Kazakhstan in 2006 and the Gross intake ratio(%) in Uganda in 2007?
Provide a short and direct response. -46.46. What is the difference between the Gross intake ratio(%) in Kiribati in 2006 and the Gross intake ratio(%) in Uganda in 2007?
Provide a succinct answer. -14.48. What is the difference between the Gross intake ratio(%) of Croatia in 2006 and the Gross intake ratio(%) of Kazakhstan in 2008?
Provide a succinct answer. -19.18. What is the difference between the Gross intake ratio(%) of Croatia in 2006 and the Gross intake ratio(%) of Kiribati in 2008?
Keep it short and to the point. -24. What is the difference between the Gross intake ratio(%) of Croatia in 2006 and the Gross intake ratio(%) of Uganda in 2008?
Your response must be concise. -63.35. What is the difference between the Gross intake ratio(%) in Kazakhstan in 2006 and the Gross intake ratio(%) in Kiribati in 2008?
Your answer should be very brief. -13.51. What is the difference between the Gross intake ratio(%) of Kazakhstan in 2006 and the Gross intake ratio(%) of Uganda in 2008?
Your response must be concise. -52.86. What is the difference between the Gross intake ratio(%) in Kiribati in 2006 and the Gross intake ratio(%) in Uganda in 2008?
Keep it short and to the point. -20.88. What is the difference between the Gross intake ratio(%) in Croatia in 2007 and the Gross intake ratio(%) in Kazakhstan in 2008?
Offer a terse response. -22.6. What is the difference between the Gross intake ratio(%) of Croatia in 2007 and the Gross intake ratio(%) of Kiribati in 2008?
Provide a short and direct response. -27.43. What is the difference between the Gross intake ratio(%) in Croatia in 2007 and the Gross intake ratio(%) in Uganda in 2008?
Provide a short and direct response. -66.77. What is the difference between the Gross intake ratio(%) in Kazakhstan in 2007 and the Gross intake ratio(%) in Kiribati in 2008?
Your answer should be compact. -10.76. What is the difference between the Gross intake ratio(%) of Kazakhstan in 2007 and the Gross intake ratio(%) of Uganda in 2008?
Provide a short and direct response. -50.1. What is the difference between the Gross intake ratio(%) of Kiribati in 2007 and the Gross intake ratio(%) of Uganda in 2008?
Make the answer very short. -36.07. What is the average Gross intake ratio(%) in Croatia per year?
Your response must be concise. 94.19. What is the average Gross intake ratio(%) of Kazakhstan per year?
Give a very brief answer. 106.59. What is the average Gross intake ratio(%) in Kiribati per year?
Offer a terse response. 122.23. What is the average Gross intake ratio(%) of Uganda per year?
Keep it short and to the point. 165.92. In the year 2000, what is the difference between the Gross intake ratio(%) in Croatia and Gross intake ratio(%) in Kazakhstan?
Make the answer very short. -13.02. In the year 2000, what is the difference between the Gross intake ratio(%) in Croatia and Gross intake ratio(%) in Kiribati?
Make the answer very short. -18.02. In the year 2000, what is the difference between the Gross intake ratio(%) of Croatia and Gross intake ratio(%) of Uganda?
Give a very brief answer. -83.37. In the year 2000, what is the difference between the Gross intake ratio(%) of Kazakhstan and Gross intake ratio(%) of Kiribati?
Give a very brief answer. -5. In the year 2000, what is the difference between the Gross intake ratio(%) of Kazakhstan and Gross intake ratio(%) of Uganda?
Provide a succinct answer. -70.34. In the year 2000, what is the difference between the Gross intake ratio(%) in Kiribati and Gross intake ratio(%) in Uganda?
Offer a terse response. -65.34. In the year 2001, what is the difference between the Gross intake ratio(%) of Croatia and Gross intake ratio(%) of Kazakhstan?
Give a very brief answer. -14.95. In the year 2001, what is the difference between the Gross intake ratio(%) in Croatia and Gross intake ratio(%) in Kiribati?
Ensure brevity in your answer.  -22.16. In the year 2001, what is the difference between the Gross intake ratio(%) of Croatia and Gross intake ratio(%) of Uganda?
Your answer should be very brief. -85.21. In the year 2001, what is the difference between the Gross intake ratio(%) of Kazakhstan and Gross intake ratio(%) of Kiribati?
Offer a terse response. -7.22. In the year 2001, what is the difference between the Gross intake ratio(%) of Kazakhstan and Gross intake ratio(%) of Uganda?
Provide a succinct answer. -70.26. In the year 2001, what is the difference between the Gross intake ratio(%) of Kiribati and Gross intake ratio(%) of Uganda?
Your response must be concise. -63.05. In the year 2002, what is the difference between the Gross intake ratio(%) in Croatia and Gross intake ratio(%) in Kazakhstan?
Offer a terse response. -9.37. In the year 2002, what is the difference between the Gross intake ratio(%) in Croatia and Gross intake ratio(%) in Kiribati?
Give a very brief answer. -10.64. In the year 2002, what is the difference between the Gross intake ratio(%) in Croatia and Gross intake ratio(%) in Uganda?
Your answer should be very brief. -88.38. In the year 2002, what is the difference between the Gross intake ratio(%) of Kazakhstan and Gross intake ratio(%) of Kiribati?
Offer a terse response. -1.27. In the year 2002, what is the difference between the Gross intake ratio(%) in Kazakhstan and Gross intake ratio(%) in Uganda?
Ensure brevity in your answer.  -79. In the year 2002, what is the difference between the Gross intake ratio(%) in Kiribati and Gross intake ratio(%) in Uganda?
Offer a terse response. -77.74. In the year 2003, what is the difference between the Gross intake ratio(%) in Croatia and Gross intake ratio(%) in Kazakhstan?
Provide a short and direct response. -6.1. In the year 2003, what is the difference between the Gross intake ratio(%) in Croatia and Gross intake ratio(%) in Kiribati?
Provide a succinct answer. -33.8. In the year 2003, what is the difference between the Gross intake ratio(%) in Croatia and Gross intake ratio(%) in Uganda?
Give a very brief answer. -82.22. In the year 2003, what is the difference between the Gross intake ratio(%) in Kazakhstan and Gross intake ratio(%) in Kiribati?
Your answer should be very brief. -27.69. In the year 2003, what is the difference between the Gross intake ratio(%) of Kazakhstan and Gross intake ratio(%) of Uganda?
Your answer should be very brief. -76.12. In the year 2003, what is the difference between the Gross intake ratio(%) of Kiribati and Gross intake ratio(%) of Uganda?
Keep it short and to the point. -48.42. In the year 2005, what is the difference between the Gross intake ratio(%) of Croatia and Gross intake ratio(%) of Kazakhstan?
Offer a terse response. -6.06. In the year 2005, what is the difference between the Gross intake ratio(%) in Croatia and Gross intake ratio(%) in Kiribati?
Your answer should be compact. -39.23. In the year 2005, what is the difference between the Gross intake ratio(%) in Croatia and Gross intake ratio(%) in Uganda?
Offer a very short reply. -54.38. In the year 2005, what is the difference between the Gross intake ratio(%) of Kazakhstan and Gross intake ratio(%) of Kiribati?
Provide a succinct answer. -33.17. In the year 2005, what is the difference between the Gross intake ratio(%) in Kazakhstan and Gross intake ratio(%) in Uganda?
Your response must be concise. -48.32. In the year 2005, what is the difference between the Gross intake ratio(%) of Kiribati and Gross intake ratio(%) of Uganda?
Your response must be concise. -15.15. In the year 2006, what is the difference between the Gross intake ratio(%) of Croatia and Gross intake ratio(%) of Kazakhstan?
Provide a succinct answer. -10.49. In the year 2006, what is the difference between the Gross intake ratio(%) in Croatia and Gross intake ratio(%) in Kiribati?
Provide a short and direct response. -42.47. In the year 2006, what is the difference between the Gross intake ratio(%) in Croatia and Gross intake ratio(%) in Uganda?
Make the answer very short. -53.25. In the year 2006, what is the difference between the Gross intake ratio(%) in Kazakhstan and Gross intake ratio(%) in Kiribati?
Offer a very short reply. -31.98. In the year 2006, what is the difference between the Gross intake ratio(%) of Kazakhstan and Gross intake ratio(%) of Uganda?
Your answer should be compact. -42.76. In the year 2006, what is the difference between the Gross intake ratio(%) in Kiribati and Gross intake ratio(%) in Uganda?
Ensure brevity in your answer.  -10.78. In the year 2007, what is the difference between the Gross intake ratio(%) in Croatia and Gross intake ratio(%) in Kazakhstan?
Offer a very short reply. -16.67. In the year 2007, what is the difference between the Gross intake ratio(%) of Croatia and Gross intake ratio(%) of Kiribati?
Offer a very short reply. -30.71. In the year 2007, what is the difference between the Gross intake ratio(%) of Croatia and Gross intake ratio(%) of Uganda?
Offer a terse response. -60.37. In the year 2007, what is the difference between the Gross intake ratio(%) in Kazakhstan and Gross intake ratio(%) in Kiribati?
Your response must be concise. -14.04. In the year 2007, what is the difference between the Gross intake ratio(%) in Kazakhstan and Gross intake ratio(%) in Uganda?
Provide a short and direct response. -43.7. In the year 2007, what is the difference between the Gross intake ratio(%) of Kiribati and Gross intake ratio(%) of Uganda?
Give a very brief answer. -29.66. In the year 2008, what is the difference between the Gross intake ratio(%) in Croatia and Gross intake ratio(%) in Kazakhstan?
Give a very brief answer. -22.5. In the year 2008, what is the difference between the Gross intake ratio(%) in Croatia and Gross intake ratio(%) in Kiribati?
Your answer should be very brief. -27.32. In the year 2008, what is the difference between the Gross intake ratio(%) in Croatia and Gross intake ratio(%) in Uganda?
Ensure brevity in your answer.  -66.67. In the year 2008, what is the difference between the Gross intake ratio(%) of Kazakhstan and Gross intake ratio(%) of Kiribati?
Ensure brevity in your answer.  -4.82. In the year 2008, what is the difference between the Gross intake ratio(%) in Kazakhstan and Gross intake ratio(%) in Uganda?
Provide a short and direct response. -44.17. In the year 2008, what is the difference between the Gross intake ratio(%) in Kiribati and Gross intake ratio(%) in Uganda?
Offer a terse response. -39.35. What is the ratio of the Gross intake ratio(%) in Kazakhstan in 2000 to that in 2001?
Make the answer very short. 0.97. What is the ratio of the Gross intake ratio(%) in Kiribati in 2000 to that in 2001?
Give a very brief answer. 0.95. What is the ratio of the Gross intake ratio(%) in Uganda in 2000 to that in 2001?
Give a very brief answer. 0.98. What is the ratio of the Gross intake ratio(%) in Croatia in 2000 to that in 2002?
Your answer should be compact. 0.93. What is the ratio of the Gross intake ratio(%) in Kazakhstan in 2000 to that in 2002?
Your answer should be compact. 0.97. What is the ratio of the Gross intake ratio(%) in Uganda in 2000 to that in 2002?
Keep it short and to the point. 0.94. What is the ratio of the Gross intake ratio(%) in Croatia in 2000 to that in 2003?
Make the answer very short. 0.94. What is the ratio of the Gross intake ratio(%) in Kazakhstan in 2000 to that in 2003?
Make the answer very short. 1.01. What is the ratio of the Gross intake ratio(%) in Kiribati in 2000 to that in 2003?
Provide a succinct answer. 0.83. What is the ratio of the Gross intake ratio(%) of Uganda in 2000 to that in 2003?
Offer a terse response. 0.97. What is the ratio of the Gross intake ratio(%) of Croatia in 2000 to that in 2005?
Give a very brief answer. 0.94. What is the ratio of the Gross intake ratio(%) in Kazakhstan in 2000 to that in 2005?
Offer a very short reply. 1.01. What is the ratio of the Gross intake ratio(%) in Kiribati in 2000 to that in 2005?
Offer a very short reply. 0.8. What is the ratio of the Gross intake ratio(%) in Uganda in 2000 to that in 2005?
Offer a terse response. 1.15. What is the ratio of the Gross intake ratio(%) of Croatia in 2000 to that in 2006?
Provide a short and direct response. 0.99. What is the ratio of the Gross intake ratio(%) in Kazakhstan in 2000 to that in 2006?
Give a very brief answer. 1.01. What is the ratio of the Gross intake ratio(%) of Kiribati in 2000 to that in 2006?
Offer a terse response. 0.81. What is the ratio of the Gross intake ratio(%) of Uganda in 2000 to that in 2006?
Keep it short and to the point. 1.2. What is the ratio of the Gross intake ratio(%) in Croatia in 2000 to that in 2007?
Give a very brief answer. 1.02. What is the ratio of the Gross intake ratio(%) in Kazakhstan in 2000 to that in 2007?
Keep it short and to the point. 0.99. What is the ratio of the Gross intake ratio(%) in Uganda in 2000 to that in 2007?
Give a very brief answer. 1.17. What is the ratio of the Gross intake ratio(%) of Croatia in 2000 to that in 2008?
Offer a terse response. 1.02. What is the ratio of the Gross intake ratio(%) in Kazakhstan in 2000 to that in 2008?
Provide a succinct answer. 0.93. What is the ratio of the Gross intake ratio(%) in Kiribati in 2000 to that in 2008?
Your response must be concise. 0.94. What is the ratio of the Gross intake ratio(%) in Uganda in 2000 to that in 2008?
Offer a terse response. 1.12. What is the ratio of the Gross intake ratio(%) of Croatia in 2001 to that in 2002?
Ensure brevity in your answer.  0.95. What is the ratio of the Gross intake ratio(%) of Kazakhstan in 2001 to that in 2002?
Provide a succinct answer. 1. What is the ratio of the Gross intake ratio(%) in Kiribati in 2001 to that in 2002?
Keep it short and to the point. 1.06. What is the ratio of the Gross intake ratio(%) of Uganda in 2001 to that in 2002?
Your response must be concise. 0.96. What is the ratio of the Gross intake ratio(%) of Croatia in 2001 to that in 2003?
Give a very brief answer. 0.95. What is the ratio of the Gross intake ratio(%) in Kazakhstan in 2001 to that in 2003?
Keep it short and to the point. 1.04. What is the ratio of the Gross intake ratio(%) of Kiribati in 2001 to that in 2003?
Your answer should be compact. 0.88. What is the ratio of the Gross intake ratio(%) in Croatia in 2001 to that in 2005?
Your answer should be compact. 0.95. What is the ratio of the Gross intake ratio(%) in Kazakhstan in 2001 to that in 2005?
Keep it short and to the point. 1.04. What is the ratio of the Gross intake ratio(%) of Kiribati in 2001 to that in 2005?
Offer a very short reply. 0.84. What is the ratio of the Gross intake ratio(%) of Uganda in 2001 to that in 2005?
Offer a terse response. 1.17. What is the ratio of the Gross intake ratio(%) in Croatia in 2001 to that in 2006?
Offer a very short reply. 1. What is the ratio of the Gross intake ratio(%) in Kazakhstan in 2001 to that in 2006?
Provide a succinct answer. 1.04. What is the ratio of the Gross intake ratio(%) of Kiribati in 2001 to that in 2006?
Give a very brief answer. 0.85. What is the ratio of the Gross intake ratio(%) in Uganda in 2001 to that in 2006?
Ensure brevity in your answer.  1.22. What is the ratio of the Gross intake ratio(%) of Croatia in 2001 to that in 2007?
Offer a very short reply. 1.04. What is the ratio of the Gross intake ratio(%) of Kazakhstan in 2001 to that in 2007?
Your answer should be very brief. 1.02. What is the ratio of the Gross intake ratio(%) of Uganda in 2001 to that in 2007?
Keep it short and to the point. 1.19. What is the ratio of the Gross intake ratio(%) of Croatia in 2001 to that in 2008?
Give a very brief answer. 1.04. What is the ratio of the Gross intake ratio(%) of Kazakhstan in 2001 to that in 2008?
Offer a terse response. 0.96. What is the ratio of the Gross intake ratio(%) of Kiribati in 2001 to that in 2008?
Offer a very short reply. 0.99. What is the ratio of the Gross intake ratio(%) in Uganda in 2001 to that in 2008?
Provide a succinct answer. 1.14. What is the ratio of the Gross intake ratio(%) in Croatia in 2002 to that in 2003?
Offer a very short reply. 1.01. What is the ratio of the Gross intake ratio(%) in Kazakhstan in 2002 to that in 2003?
Your answer should be very brief. 1.04. What is the ratio of the Gross intake ratio(%) of Kiribati in 2002 to that in 2003?
Offer a terse response. 0.83. What is the ratio of the Gross intake ratio(%) in Uganda in 2002 to that in 2003?
Offer a very short reply. 1.04. What is the ratio of the Gross intake ratio(%) in Kazakhstan in 2002 to that in 2005?
Provide a succinct answer. 1.03. What is the ratio of the Gross intake ratio(%) of Kiribati in 2002 to that in 2005?
Your answer should be very brief. 0.79. What is the ratio of the Gross intake ratio(%) in Uganda in 2002 to that in 2005?
Ensure brevity in your answer.  1.23. What is the ratio of the Gross intake ratio(%) in Croatia in 2002 to that in 2006?
Provide a succinct answer. 1.06. What is the ratio of the Gross intake ratio(%) in Kazakhstan in 2002 to that in 2006?
Your response must be concise. 1.04. What is the ratio of the Gross intake ratio(%) in Kiribati in 2002 to that in 2006?
Make the answer very short. 0.8. What is the ratio of the Gross intake ratio(%) of Uganda in 2002 to that in 2006?
Your response must be concise. 1.28. What is the ratio of the Gross intake ratio(%) in Croatia in 2002 to that in 2007?
Keep it short and to the point. 1.1. What is the ratio of the Gross intake ratio(%) in Kazakhstan in 2002 to that in 2007?
Your response must be concise. 1.01. What is the ratio of the Gross intake ratio(%) in Kiribati in 2002 to that in 2007?
Keep it short and to the point. 0.91. What is the ratio of the Gross intake ratio(%) of Uganda in 2002 to that in 2007?
Offer a terse response. 1.24. What is the ratio of the Gross intake ratio(%) of Croatia in 2002 to that in 2008?
Your response must be concise. 1.1. What is the ratio of the Gross intake ratio(%) of Kazakhstan in 2002 to that in 2008?
Your answer should be very brief. 0.96. What is the ratio of the Gross intake ratio(%) of Kiribati in 2002 to that in 2008?
Your response must be concise. 0.93. What is the ratio of the Gross intake ratio(%) of Uganda in 2002 to that in 2008?
Offer a very short reply. 1.19. What is the ratio of the Gross intake ratio(%) of Croatia in 2003 to that in 2005?
Ensure brevity in your answer.  1. What is the ratio of the Gross intake ratio(%) in Kazakhstan in 2003 to that in 2005?
Offer a very short reply. 1. What is the ratio of the Gross intake ratio(%) of Kiribati in 2003 to that in 2005?
Keep it short and to the point. 0.96. What is the ratio of the Gross intake ratio(%) of Uganda in 2003 to that in 2005?
Your answer should be compact. 1.18. What is the ratio of the Gross intake ratio(%) of Croatia in 2003 to that in 2006?
Your answer should be very brief. 1.05. What is the ratio of the Gross intake ratio(%) in Kiribati in 2003 to that in 2006?
Offer a terse response. 0.97. What is the ratio of the Gross intake ratio(%) in Uganda in 2003 to that in 2006?
Offer a very short reply. 1.23. What is the ratio of the Gross intake ratio(%) of Croatia in 2003 to that in 2007?
Give a very brief answer. 1.09. What is the ratio of the Gross intake ratio(%) of Kazakhstan in 2003 to that in 2007?
Offer a very short reply. 0.98. What is the ratio of the Gross intake ratio(%) of Kiribati in 2003 to that in 2007?
Provide a succinct answer. 1.09. What is the ratio of the Gross intake ratio(%) of Uganda in 2003 to that in 2007?
Keep it short and to the point. 1.2. What is the ratio of the Gross intake ratio(%) in Croatia in 2003 to that in 2008?
Keep it short and to the point. 1.09. What is the ratio of the Gross intake ratio(%) in Kazakhstan in 2003 to that in 2008?
Keep it short and to the point. 0.93. What is the ratio of the Gross intake ratio(%) in Kiribati in 2003 to that in 2008?
Provide a short and direct response. 1.12. What is the ratio of the Gross intake ratio(%) in Uganda in 2003 to that in 2008?
Offer a very short reply. 1.15. What is the ratio of the Gross intake ratio(%) of Croatia in 2005 to that in 2006?
Your response must be concise. 1.05. What is the ratio of the Gross intake ratio(%) in Kiribati in 2005 to that in 2006?
Your response must be concise. 1.01. What is the ratio of the Gross intake ratio(%) in Uganda in 2005 to that in 2006?
Make the answer very short. 1.04. What is the ratio of the Gross intake ratio(%) of Croatia in 2005 to that in 2007?
Offer a very short reply. 1.09. What is the ratio of the Gross intake ratio(%) in Kazakhstan in 2005 to that in 2007?
Offer a very short reply. 0.98. What is the ratio of the Gross intake ratio(%) of Kiribati in 2005 to that in 2007?
Provide a succinct answer. 1.14. What is the ratio of the Gross intake ratio(%) in Croatia in 2005 to that in 2008?
Provide a succinct answer. 1.09. What is the ratio of the Gross intake ratio(%) in Kazakhstan in 2005 to that in 2008?
Ensure brevity in your answer.  0.93. What is the ratio of the Gross intake ratio(%) of Kiribati in 2005 to that in 2008?
Offer a terse response. 1.17. What is the ratio of the Gross intake ratio(%) in Uganda in 2005 to that in 2008?
Give a very brief answer. 0.97. What is the ratio of the Gross intake ratio(%) of Croatia in 2006 to that in 2007?
Provide a succinct answer. 1.04. What is the ratio of the Gross intake ratio(%) in Kazakhstan in 2006 to that in 2007?
Offer a terse response. 0.97. What is the ratio of the Gross intake ratio(%) in Kiribati in 2006 to that in 2007?
Provide a short and direct response. 1.13. What is the ratio of the Gross intake ratio(%) of Uganda in 2006 to that in 2007?
Ensure brevity in your answer.  0.98. What is the ratio of the Gross intake ratio(%) of Croatia in 2006 to that in 2008?
Provide a short and direct response. 1.04. What is the ratio of the Gross intake ratio(%) in Kazakhstan in 2006 to that in 2008?
Provide a short and direct response. 0.92. What is the ratio of the Gross intake ratio(%) of Kiribati in 2006 to that in 2008?
Your answer should be compact. 1.16. What is the ratio of the Gross intake ratio(%) in Uganda in 2006 to that in 2008?
Your answer should be very brief. 0.94. What is the ratio of the Gross intake ratio(%) in Kazakhstan in 2007 to that in 2008?
Your answer should be compact. 0.95. What is the ratio of the Gross intake ratio(%) of Kiribati in 2007 to that in 2008?
Your response must be concise. 1.03. What is the ratio of the Gross intake ratio(%) in Uganda in 2007 to that in 2008?
Your response must be concise. 0.96. What is the difference between the highest and the second highest Gross intake ratio(%) of Croatia?
Your answer should be very brief. 0.33. What is the difference between the highest and the second highest Gross intake ratio(%) of Kazakhstan?
Your answer should be very brief. 4.05. What is the difference between the highest and the second highest Gross intake ratio(%) of Kiribati?
Give a very brief answer. 1.73. What is the difference between the highest and the second highest Gross intake ratio(%) of Uganda?
Make the answer very short. 6.68. What is the difference between the highest and the lowest Gross intake ratio(%) of Croatia?
Make the answer very short. 8.73. What is the difference between the highest and the lowest Gross intake ratio(%) in Kazakhstan?
Provide a succinct answer. 8.69. What is the difference between the highest and the lowest Gross intake ratio(%) in Kiribati?
Provide a succinct answer. 28.25. What is the difference between the highest and the lowest Gross intake ratio(%) in Uganda?
Give a very brief answer. 40.43. 